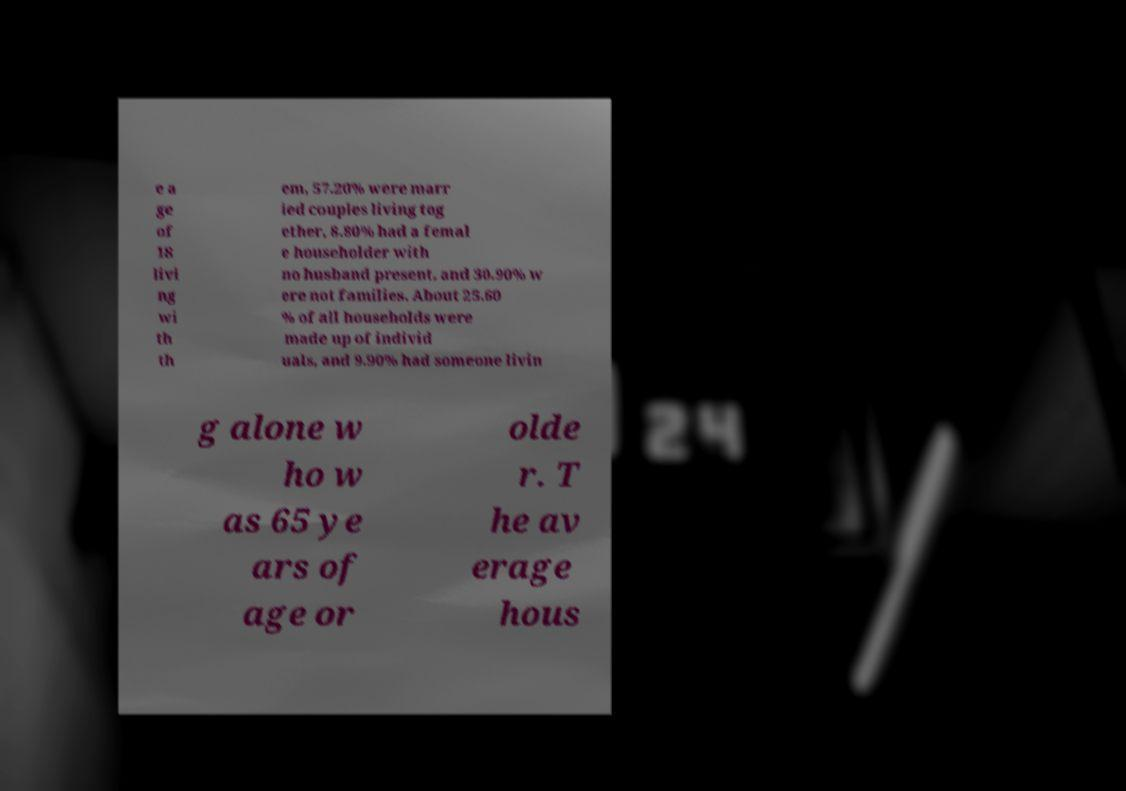Can you accurately transcribe the text from the provided image for me? e a ge of 18 livi ng wi th th em, 57.20% were marr ied couples living tog ether, 8.80% had a femal e householder with no husband present, and 30.90% w ere not families. About 25.60 % of all households were made up of individ uals, and 9.90% had someone livin g alone w ho w as 65 ye ars of age or olde r. T he av erage hous 